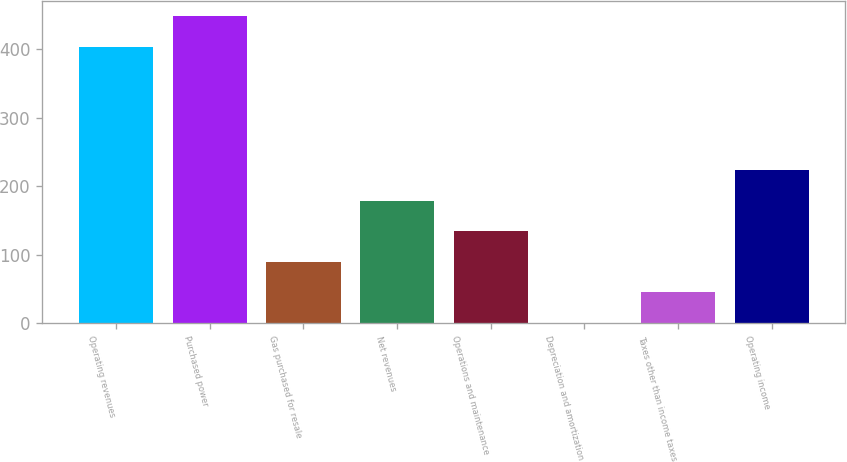Convert chart to OTSL. <chart><loc_0><loc_0><loc_500><loc_500><bar_chart><fcel>Operating revenues<fcel>Purchased power<fcel>Gas purchased for resale<fcel>Net revenues<fcel>Operations and maintenance<fcel>Depreciation and amortization<fcel>Taxes other than income taxes<fcel>Operating income<nl><fcel>404<fcel>448.6<fcel>90.2<fcel>179.4<fcel>134.8<fcel>1<fcel>45.6<fcel>224<nl></chart> 